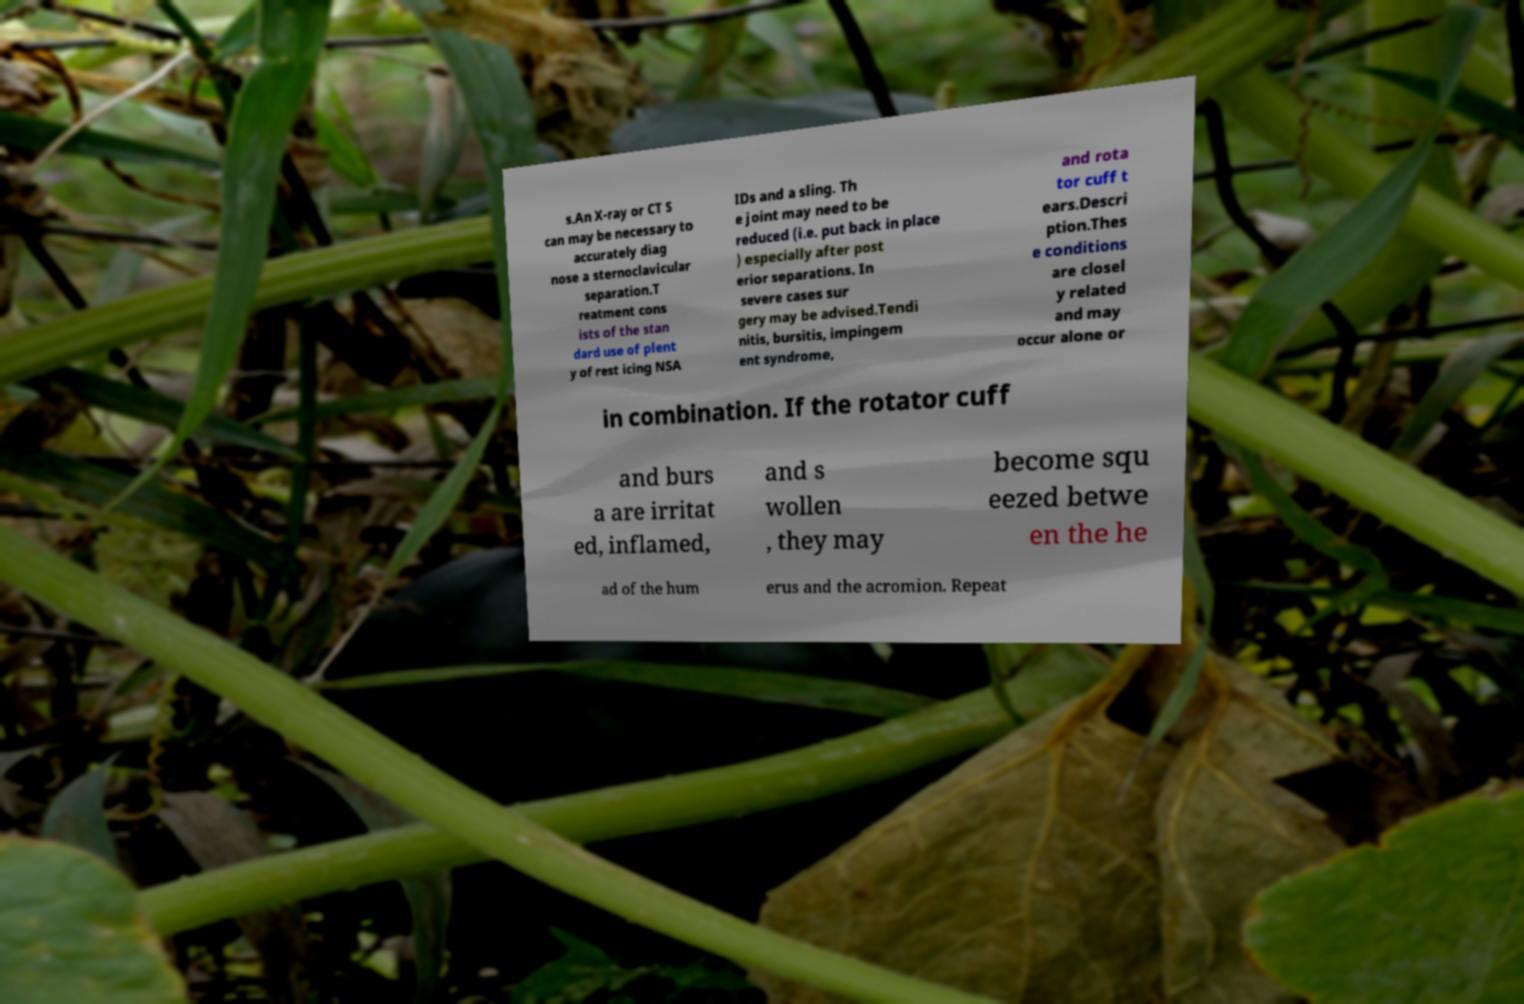For documentation purposes, I need the text within this image transcribed. Could you provide that? s.An X-ray or CT S can may be necessary to accurately diag nose a sternoclavicular separation.T reatment cons ists of the stan dard use of plent y of rest icing NSA IDs and a sling. Th e joint may need to be reduced (i.e. put back in place ) especially after post erior separations. In severe cases sur gery may be advised.Tendi nitis, bursitis, impingem ent syndrome, and rota tor cuff t ears.Descri ption.Thes e conditions are closel y related and may occur alone or in combination. If the rotator cuff and burs a are irritat ed, inflamed, and s wollen , they may become squ eezed betwe en the he ad of the hum erus and the acromion. Repeat 